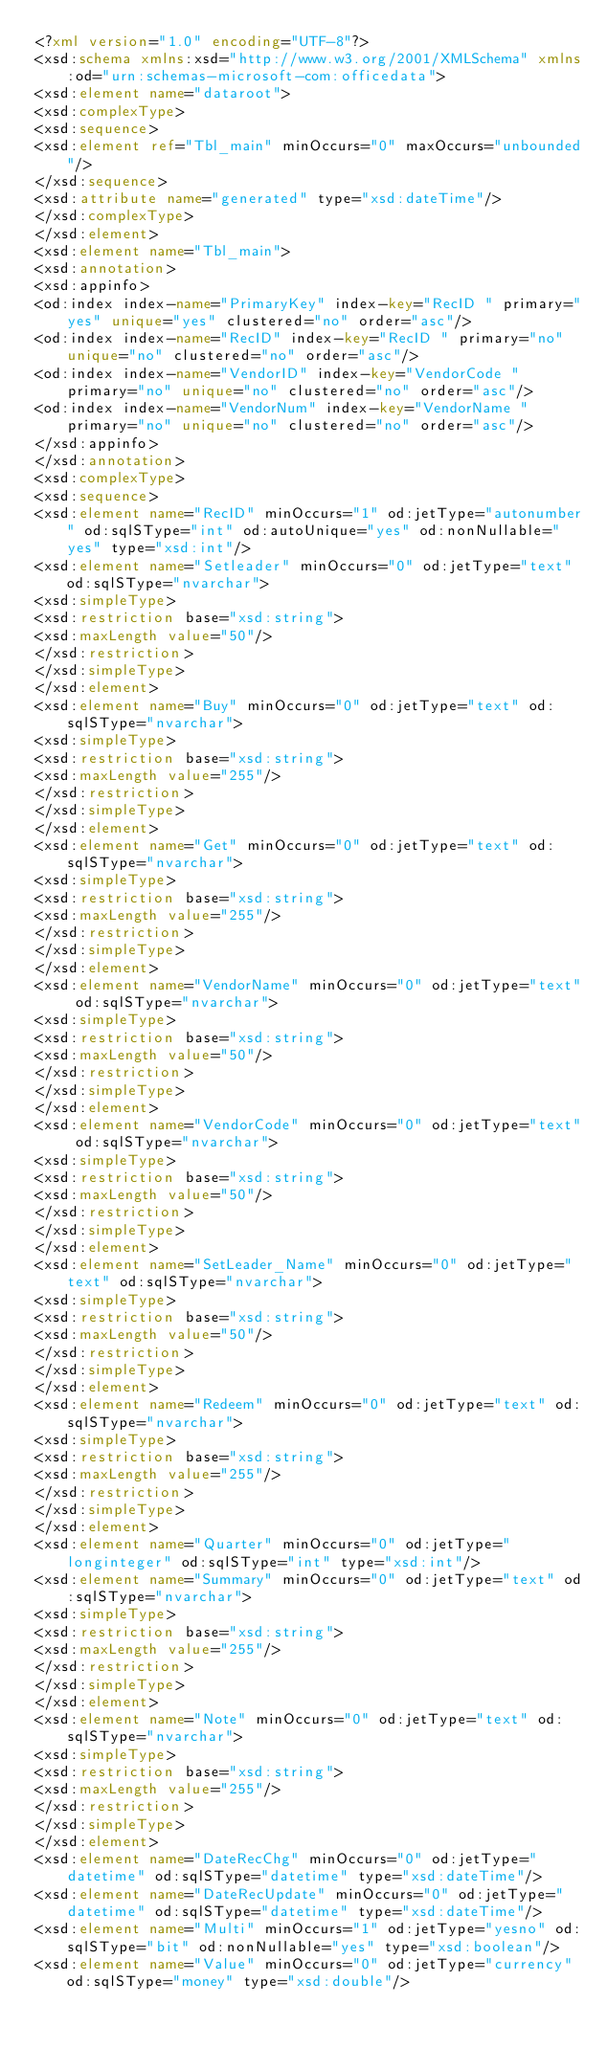Convert code to text. <code><loc_0><loc_0><loc_500><loc_500><_XML_><?xml version="1.0" encoding="UTF-8"?>
<xsd:schema xmlns:xsd="http://www.w3.org/2001/XMLSchema" xmlns:od="urn:schemas-microsoft-com:officedata">
<xsd:element name="dataroot">
<xsd:complexType>
<xsd:sequence>
<xsd:element ref="Tbl_main" minOccurs="0" maxOccurs="unbounded"/>
</xsd:sequence>
<xsd:attribute name="generated" type="xsd:dateTime"/>
</xsd:complexType>
</xsd:element>
<xsd:element name="Tbl_main">
<xsd:annotation>
<xsd:appinfo>
<od:index index-name="PrimaryKey" index-key="RecID " primary="yes" unique="yes" clustered="no" order="asc"/>
<od:index index-name="RecID" index-key="RecID " primary="no" unique="no" clustered="no" order="asc"/>
<od:index index-name="VendorID" index-key="VendorCode " primary="no" unique="no" clustered="no" order="asc"/>
<od:index index-name="VendorNum" index-key="VendorName " primary="no" unique="no" clustered="no" order="asc"/>
</xsd:appinfo>
</xsd:annotation>
<xsd:complexType>
<xsd:sequence>
<xsd:element name="RecID" minOccurs="1" od:jetType="autonumber" od:sqlSType="int" od:autoUnique="yes" od:nonNullable="yes" type="xsd:int"/>
<xsd:element name="Setleader" minOccurs="0" od:jetType="text" od:sqlSType="nvarchar">
<xsd:simpleType>
<xsd:restriction base="xsd:string">
<xsd:maxLength value="50"/>
</xsd:restriction>
</xsd:simpleType>
</xsd:element>
<xsd:element name="Buy" minOccurs="0" od:jetType="text" od:sqlSType="nvarchar">
<xsd:simpleType>
<xsd:restriction base="xsd:string">
<xsd:maxLength value="255"/>
</xsd:restriction>
</xsd:simpleType>
</xsd:element>
<xsd:element name="Get" minOccurs="0" od:jetType="text" od:sqlSType="nvarchar">
<xsd:simpleType>
<xsd:restriction base="xsd:string">
<xsd:maxLength value="255"/>
</xsd:restriction>
</xsd:simpleType>
</xsd:element>
<xsd:element name="VendorName" minOccurs="0" od:jetType="text" od:sqlSType="nvarchar">
<xsd:simpleType>
<xsd:restriction base="xsd:string">
<xsd:maxLength value="50"/>
</xsd:restriction>
</xsd:simpleType>
</xsd:element>
<xsd:element name="VendorCode" minOccurs="0" od:jetType="text" od:sqlSType="nvarchar">
<xsd:simpleType>
<xsd:restriction base="xsd:string">
<xsd:maxLength value="50"/>
</xsd:restriction>
</xsd:simpleType>
</xsd:element>
<xsd:element name="SetLeader_Name" minOccurs="0" od:jetType="text" od:sqlSType="nvarchar">
<xsd:simpleType>
<xsd:restriction base="xsd:string">
<xsd:maxLength value="50"/>
</xsd:restriction>
</xsd:simpleType>
</xsd:element>
<xsd:element name="Redeem" minOccurs="0" od:jetType="text" od:sqlSType="nvarchar">
<xsd:simpleType>
<xsd:restriction base="xsd:string">
<xsd:maxLength value="255"/>
</xsd:restriction>
</xsd:simpleType>
</xsd:element>
<xsd:element name="Quarter" minOccurs="0" od:jetType="longinteger" od:sqlSType="int" type="xsd:int"/>
<xsd:element name="Summary" minOccurs="0" od:jetType="text" od:sqlSType="nvarchar">
<xsd:simpleType>
<xsd:restriction base="xsd:string">
<xsd:maxLength value="255"/>
</xsd:restriction>
</xsd:simpleType>
</xsd:element>
<xsd:element name="Note" minOccurs="0" od:jetType="text" od:sqlSType="nvarchar">
<xsd:simpleType>
<xsd:restriction base="xsd:string">
<xsd:maxLength value="255"/>
</xsd:restriction>
</xsd:simpleType>
</xsd:element>
<xsd:element name="DateRecChg" minOccurs="0" od:jetType="datetime" od:sqlSType="datetime" type="xsd:dateTime"/>
<xsd:element name="DateRecUpdate" minOccurs="0" od:jetType="datetime" od:sqlSType="datetime" type="xsd:dateTime"/>
<xsd:element name="Multi" minOccurs="1" od:jetType="yesno" od:sqlSType="bit" od:nonNullable="yes" type="xsd:boolean"/>
<xsd:element name="Value" minOccurs="0" od:jetType="currency" od:sqlSType="money" type="xsd:double"/></code> 